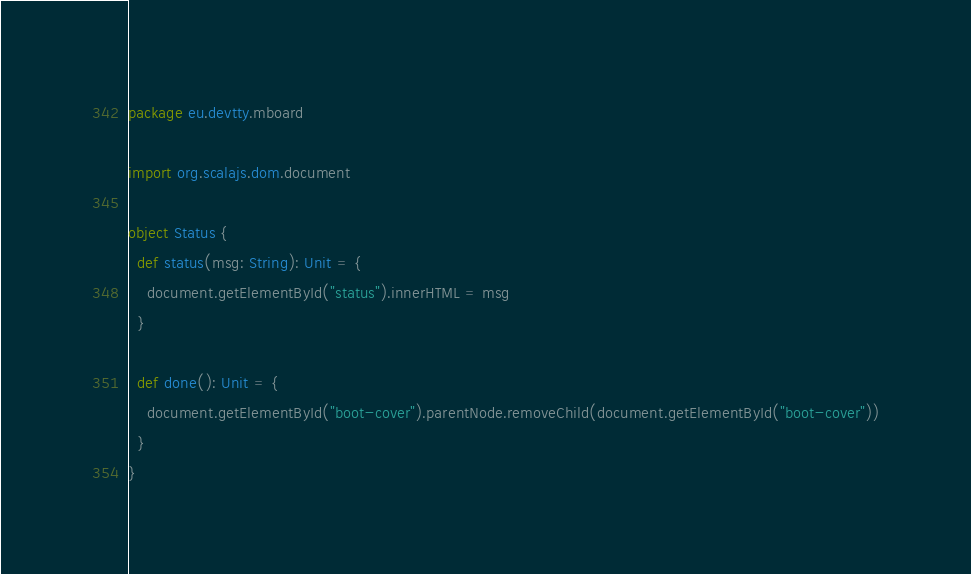<code> <loc_0><loc_0><loc_500><loc_500><_Scala_>package eu.devtty.mboard

import org.scalajs.dom.document

object Status {
  def status(msg: String): Unit = {
    document.getElementById("status").innerHTML = msg
  }

  def done(): Unit = {
    document.getElementById("boot-cover").parentNode.removeChild(document.getElementById("boot-cover"))
  }
}
</code> 